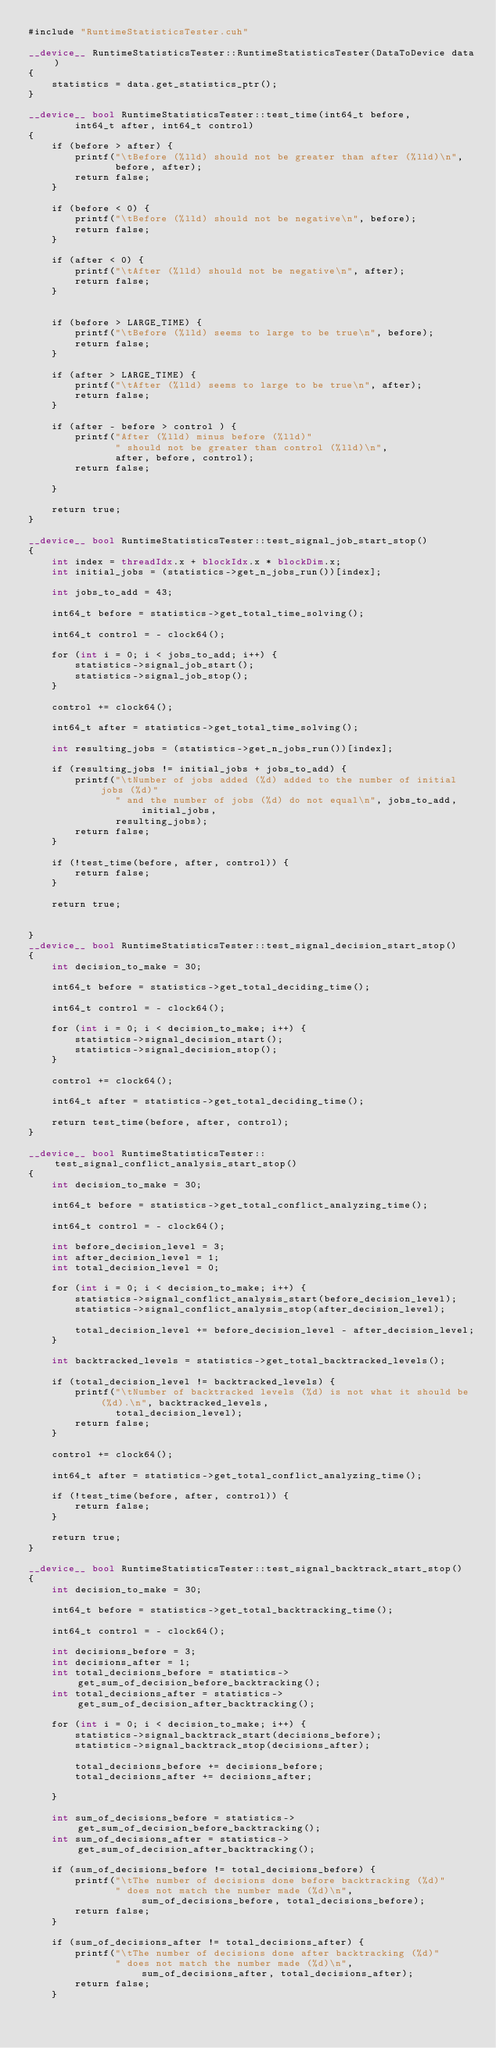Convert code to text. <code><loc_0><loc_0><loc_500><loc_500><_Cuda_>#include "RuntimeStatisticsTester.cuh"

__device__ RuntimeStatisticsTester::RuntimeStatisticsTester(DataToDevice data)
{
    statistics = data.get_statistics_ptr();
}

__device__ bool RuntimeStatisticsTester::test_time(int64_t before,
        int64_t after, int64_t control)
{
    if (before > after) {
        printf("\tBefore (%lld) should not be greater than after (%lld)\n",
               before, after);
        return false;
    }

    if (before < 0) {
        printf("\tBefore (%lld) should not be negative\n", before);
        return false;
    }

    if (after < 0) {
        printf("\tAfter (%lld) should not be negative\n", after);
        return false;
    }


    if (before > LARGE_TIME) {
        printf("\tBefore (%lld) seems to large to be true\n", before);
        return false;
    }

    if (after > LARGE_TIME) {
        printf("\tAfter (%lld) seems to large to be true\n", after);
        return false;
    }

    if (after - before > control ) {
        printf("After (%lld) minus before (%lld)"
               " should not be greater than control (%lld)\n",
               after, before, control);
        return false;

    }

    return true;
}

__device__ bool RuntimeStatisticsTester::test_signal_job_start_stop()
{
    int index = threadIdx.x + blockIdx.x * blockDim.x;
    int initial_jobs = (statistics->get_n_jobs_run())[index];

    int jobs_to_add = 43;

    int64_t before = statistics->get_total_time_solving();

    int64_t control = - clock64();

    for (int i = 0; i < jobs_to_add; i++) {
        statistics->signal_job_start();
        statistics->signal_job_stop();
    }

    control += clock64();

    int64_t after = statistics->get_total_time_solving();

    int resulting_jobs = (statistics->get_n_jobs_run())[index];

    if (resulting_jobs != initial_jobs + jobs_to_add) {
        printf("\tNumber of jobs added (%d) added to the number of initial jobs (%d)"
               " and the number of jobs (%d) do not equal\n", jobs_to_add, initial_jobs,
               resulting_jobs);
        return false;
    }

    if (!test_time(before, after, control)) {
        return false;
    }

    return true;


}
__device__ bool RuntimeStatisticsTester::test_signal_decision_start_stop()
{
    int decision_to_make = 30;

    int64_t before = statistics->get_total_deciding_time();

    int64_t control = - clock64();

    for (int i = 0; i < decision_to_make; i++) {
        statistics->signal_decision_start();
        statistics->signal_decision_stop();
    }

    control += clock64();

    int64_t after = statistics->get_total_deciding_time();

    return test_time(before, after, control);
}

__device__ bool RuntimeStatisticsTester::test_signal_conflict_analysis_start_stop()
{
    int decision_to_make = 30;

    int64_t before = statistics->get_total_conflict_analyzing_time();

    int64_t control = - clock64();

    int before_decision_level = 3;
    int after_decision_level = 1;
    int total_decision_level = 0;

    for (int i = 0; i < decision_to_make; i++) {
        statistics->signal_conflict_analysis_start(before_decision_level);
        statistics->signal_conflict_analysis_stop(after_decision_level);

        total_decision_level += before_decision_level - after_decision_level;
    }

    int backtracked_levels = statistics->get_total_backtracked_levels();

    if (total_decision_level != backtracked_levels) {
        printf("\tNumber of backtracked levels (%d) is not what it should be (%d).\n", backtracked_levels,
               total_decision_level);
        return false;
    }

    control += clock64();

    int64_t after = statistics->get_total_conflict_analyzing_time();

    if (!test_time(before, after, control)) {
        return false;
    }

    return true;
}

__device__ bool RuntimeStatisticsTester::test_signal_backtrack_start_stop()
{
    int decision_to_make = 30;

    int64_t before = statistics->get_total_backtracking_time();

    int64_t control = - clock64();

    int decisions_before = 3;
    int decisions_after = 1;
    int total_decisions_before = statistics->get_sum_of_decision_before_backtracking();
    int total_decisions_after = statistics->get_sum_of_decision_after_backtracking();

    for (int i = 0; i < decision_to_make; i++) {
        statistics->signal_backtrack_start(decisions_before);
        statistics->signal_backtrack_stop(decisions_after);

        total_decisions_before += decisions_before;
        total_decisions_after += decisions_after;

    }

    int sum_of_decisions_before = statistics->get_sum_of_decision_before_backtracking();
    int sum_of_decisions_after = statistics->get_sum_of_decision_after_backtracking();

    if (sum_of_decisions_before != total_decisions_before) {
        printf("\tThe number of decisions done before backtracking (%d)"
               " does not match the number made (%d)\n", sum_of_decisions_before, total_decisions_before);
        return false;
    }

    if (sum_of_decisions_after != total_decisions_after) {
        printf("\tThe number of decisions done after backtracking (%d)"
               " does not match the number made (%d)\n", sum_of_decisions_after, total_decisions_after);
        return false;
    }
</code> 